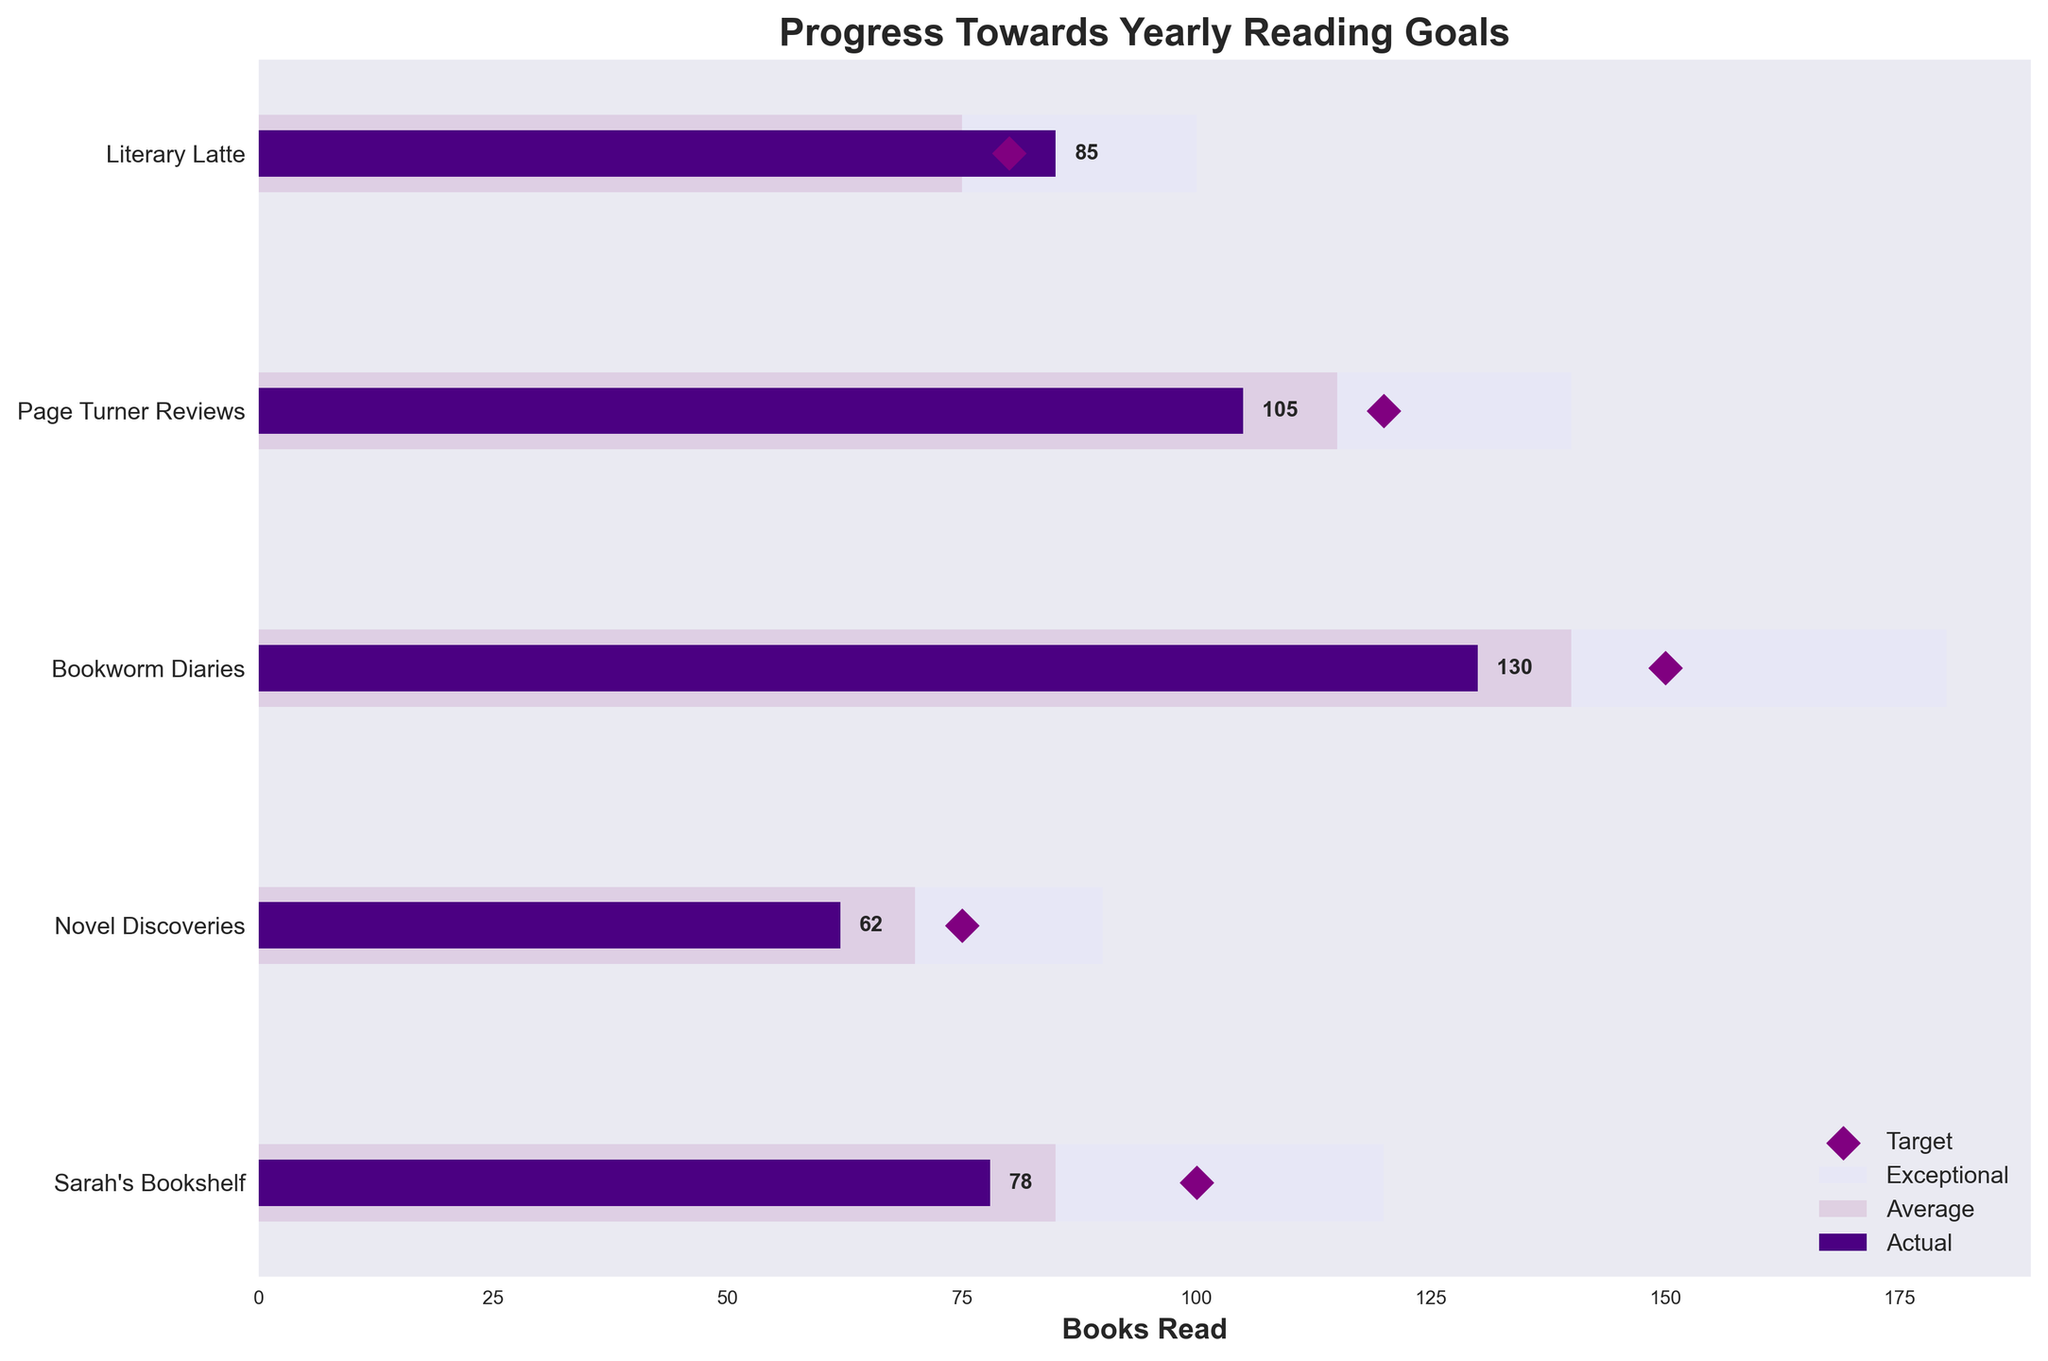What's the title of the figure? The title of the figure is located at the top and it clearly states "Progress Towards Yearly Reading Goals."
Answer: Progress Towards Yearly Reading Goals What’s the average book reading goal across all reviewers? To find the average goal, sum up all the target values and divide by the number of reviewers: (100 + 75 + 150 + 120 + 80) / 5 = 525 / 5
Answer: 105 Which reviewer has surpassed their yearly reading goal? Sarah's Bookshelf has an actual value of 78, which is less than the target; Novel Discoveries also has less; Bookworm Diaries has actual 130 which is less than target 150; Page Turner Reviews has less too; Literary Latte with actual 85 exceeds the target of 80.
Answer: Literary Latte Who's closest to meeting their Exceptional reading range? Comparing actual to exceptional: Sarah's Bookshelf is 42 books away; Novel Discoveries is 28 books away; Bookworm Diaries is 50 books away; Page Turner Reviews is 35 books away; Literary Latte is 15 books away. Therefore, Literary Latte is the closest.
Answer: Literary Latte What is the difference between the actual and target values for Page Turner Reviews? The target for Page Turner Reviews is 120 and the actual value is 105. The difference is calculated as 120 - 105 = 15.
Answer: 15 Which reviewer has the least number of actual books read? By comparing the actual values: Sarah's Bookshelf (78), Novel Discoveries (62), Bookworm Diaries (130), Page Turner Reviews (105), and Literary Latte (85), Novel Discoveries has the least.
Answer: Novel Discoveries Between Sarah's Bookshelf and Bookworm Diaries, who reads more books on average? Sarah's Bookshelf has an average of 85 books, while Bookworm Diaries has an average of 140 books.
Answer: Bookworm Diaries How many reviewers have exceeded their average reading ranges? Check actual against average for each reviewer: Sarah's Bookshelf (78 < 85), Novel Discoveries (62 < 70), Bookworm Diaries (130 < 140), Page Turner Reviews (105 < 115), Literary Latte (85 > 75). Only Literary Latte exceeds their average.
Answer: 1 Which reviewer is furthest behind their target? Calculate the difference between the target and actual for each: Sarah's Bookshelf (100 - 78 = 22), Novel Discoveries (75 - 62 = 13), Bookworm Diaries (150 - 130 = 20), Page Turner Reviews (120 - 105 = 15), and Literary Latte (80 - 85 = -5). Sarah's Bookshelf is furthest behind by 22 books.
Answer: Sarah's Bookshelf 